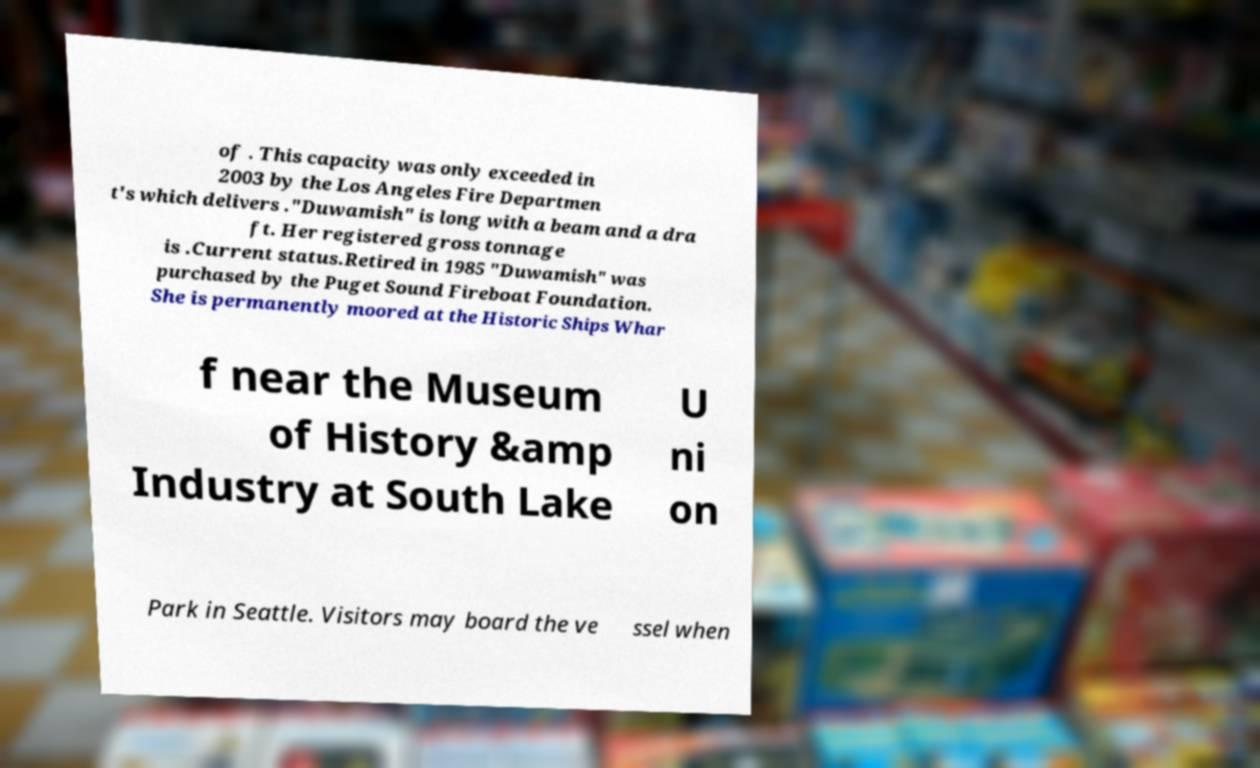Please read and relay the text visible in this image. What does it say? of . This capacity was only exceeded in 2003 by the Los Angeles Fire Departmen t's which delivers ."Duwamish" is long with a beam and a dra ft. Her registered gross tonnage is .Current status.Retired in 1985 "Duwamish" was purchased by the Puget Sound Fireboat Foundation. She is permanently moored at the Historic Ships Whar f near the Museum of History &amp Industry at South Lake U ni on Park in Seattle. Visitors may board the ve ssel when 